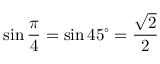<formula> <loc_0><loc_0><loc_500><loc_500>\sin { \frac { \pi } { 4 } } = \sin 4 5 ^ { \circ } = { \frac { \sqrt { 2 } } { 2 } }</formula> 